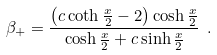Convert formula to latex. <formula><loc_0><loc_0><loc_500><loc_500>\beta _ { + } = \frac { \left ( c \coth \frac { x } { 2 } - 2 \right ) \cosh \frac { x } { 2 } } { \cosh \frac { x } { 2 } + c \sinh \frac { x } { 2 } } \ .</formula> 